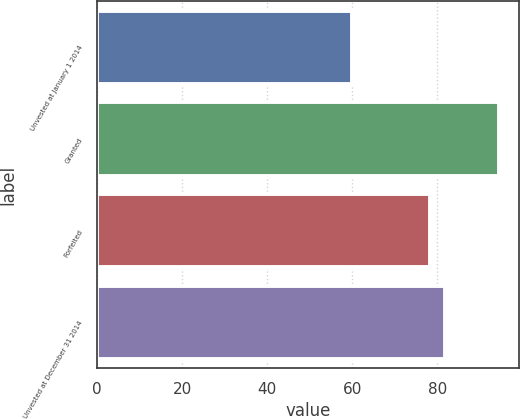Convert chart. <chart><loc_0><loc_0><loc_500><loc_500><bar_chart><fcel>Unvested at January 1 2014<fcel>Granted<fcel>Forfeited<fcel>Unvested at December 31 2014<nl><fcel>59.98<fcel>94.55<fcel>78.26<fcel>81.87<nl></chart> 